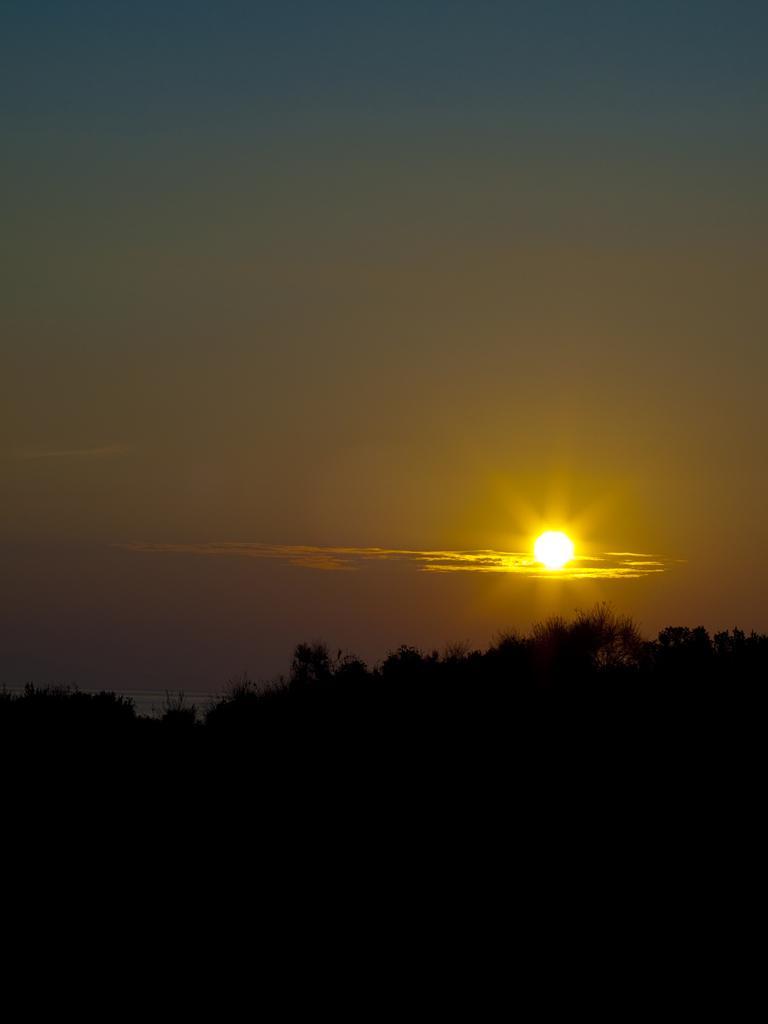Could you give a brief overview of what you see in this image? In this image, we can see the sky, sun. Here we can see few plants. At the bottom of the image, we can see dark view. 